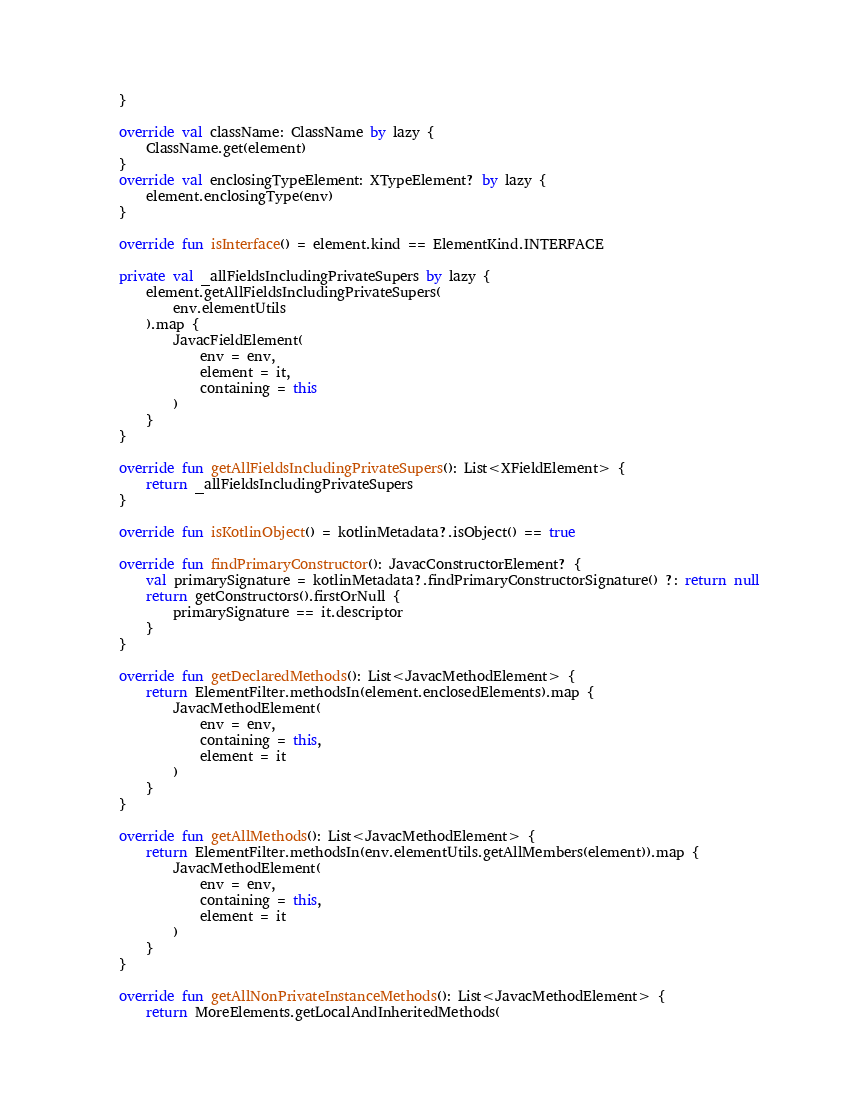<code> <loc_0><loc_0><loc_500><loc_500><_Kotlin_>    }

    override val className: ClassName by lazy {
        ClassName.get(element)
    }
    override val enclosingTypeElement: XTypeElement? by lazy {
        element.enclosingType(env)
    }

    override fun isInterface() = element.kind == ElementKind.INTERFACE

    private val _allFieldsIncludingPrivateSupers by lazy {
        element.getAllFieldsIncludingPrivateSupers(
            env.elementUtils
        ).map {
            JavacFieldElement(
                env = env,
                element = it,
                containing = this
            )
        }
    }

    override fun getAllFieldsIncludingPrivateSupers(): List<XFieldElement> {
        return _allFieldsIncludingPrivateSupers
    }

    override fun isKotlinObject() = kotlinMetadata?.isObject() == true

    override fun findPrimaryConstructor(): JavacConstructorElement? {
        val primarySignature = kotlinMetadata?.findPrimaryConstructorSignature() ?: return null
        return getConstructors().firstOrNull {
            primarySignature == it.descriptor
        }
    }

    override fun getDeclaredMethods(): List<JavacMethodElement> {
        return ElementFilter.methodsIn(element.enclosedElements).map {
            JavacMethodElement(
                env = env,
                containing = this,
                element = it
            )
        }
    }

    override fun getAllMethods(): List<JavacMethodElement> {
        return ElementFilter.methodsIn(env.elementUtils.getAllMembers(element)).map {
            JavacMethodElement(
                env = env,
                containing = this,
                element = it
            )
        }
    }

    override fun getAllNonPrivateInstanceMethods(): List<JavacMethodElement> {
        return MoreElements.getLocalAndInheritedMethods(</code> 